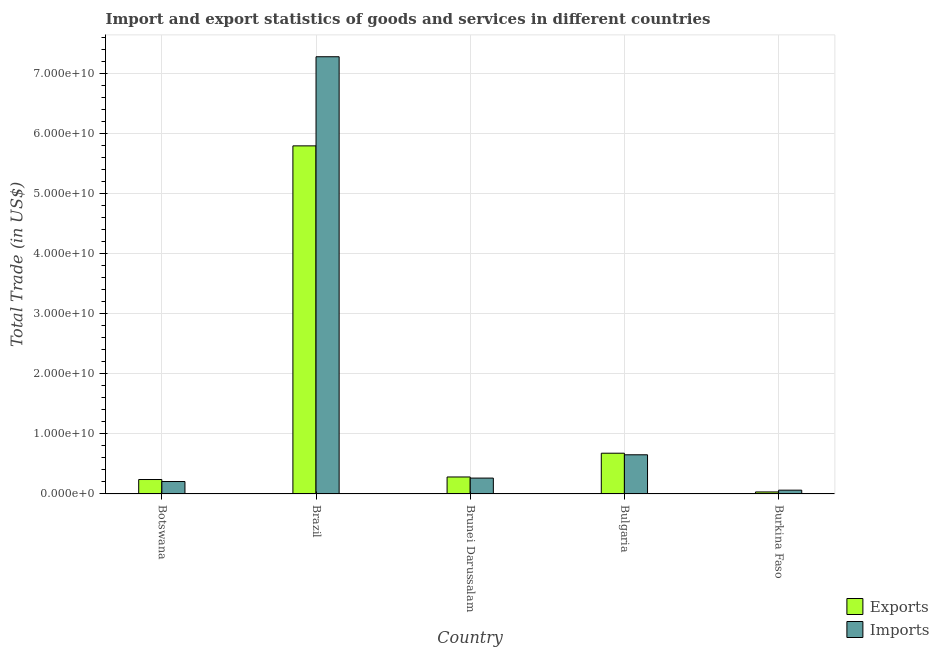How many different coloured bars are there?
Make the answer very short. 2. How many bars are there on the 3rd tick from the left?
Your response must be concise. 2. How many bars are there on the 5th tick from the right?
Provide a short and direct response. 2. What is the label of the 3rd group of bars from the left?
Offer a terse response. Brunei Darussalam. What is the export of goods and services in Brunei Darussalam?
Your response must be concise. 2.83e+09. Across all countries, what is the maximum imports of goods and services?
Offer a terse response. 7.28e+1. Across all countries, what is the minimum export of goods and services?
Provide a short and direct response. 3.36e+08. In which country was the export of goods and services minimum?
Your response must be concise. Burkina Faso. What is the total export of goods and services in the graph?
Your answer should be compact. 7.03e+1. What is the difference between the export of goods and services in Botswana and that in Bulgaria?
Provide a succinct answer. -4.38e+09. What is the difference between the imports of goods and services in Bulgaria and the export of goods and services in Burkina Faso?
Your answer should be compact. 6.18e+09. What is the average export of goods and services per country?
Ensure brevity in your answer.  1.41e+1. What is the difference between the export of goods and services and imports of goods and services in Bulgaria?
Provide a succinct answer. 2.63e+08. In how many countries, is the export of goods and services greater than 40000000000 US$?
Provide a succinct answer. 1. What is the ratio of the export of goods and services in Brunei Darussalam to that in Burkina Faso?
Give a very brief answer. 8.4. Is the export of goods and services in Brazil less than that in Bulgaria?
Give a very brief answer. No. Is the difference between the imports of goods and services in Brunei Darussalam and Bulgaria greater than the difference between the export of goods and services in Brunei Darussalam and Bulgaria?
Your response must be concise. Yes. What is the difference between the highest and the second highest export of goods and services?
Keep it short and to the point. 5.11e+1. What is the difference between the highest and the lowest export of goods and services?
Make the answer very short. 5.76e+1. Is the sum of the export of goods and services in Botswana and Bulgaria greater than the maximum imports of goods and services across all countries?
Provide a succinct answer. No. What does the 1st bar from the left in Burkina Faso represents?
Your answer should be compact. Exports. What does the 2nd bar from the right in Brazil represents?
Give a very brief answer. Exports. How many bars are there?
Offer a very short reply. 10. Are all the bars in the graph horizontal?
Your answer should be very brief. No. What is the difference between two consecutive major ticks on the Y-axis?
Provide a short and direct response. 1.00e+1. Are the values on the major ticks of Y-axis written in scientific E-notation?
Offer a very short reply. Yes. Does the graph contain grids?
Your response must be concise. Yes. How many legend labels are there?
Provide a succinct answer. 2. How are the legend labels stacked?
Keep it short and to the point. Vertical. What is the title of the graph?
Keep it short and to the point. Import and export statistics of goods and services in different countries. Does "Male labor force" appear as one of the legend labels in the graph?
Ensure brevity in your answer.  No. What is the label or title of the X-axis?
Your answer should be compact. Country. What is the label or title of the Y-axis?
Make the answer very short. Total Trade (in US$). What is the Total Trade (in US$) in Exports in Botswana?
Provide a succinct answer. 2.40e+09. What is the Total Trade (in US$) in Imports in Botswana?
Give a very brief answer. 2.07e+09. What is the Total Trade (in US$) of Exports in Brazil?
Give a very brief answer. 5.79e+1. What is the Total Trade (in US$) of Imports in Brazil?
Make the answer very short. 7.28e+1. What is the Total Trade (in US$) in Exports in Brunei Darussalam?
Your answer should be compact. 2.83e+09. What is the Total Trade (in US$) of Imports in Brunei Darussalam?
Provide a short and direct response. 2.64e+09. What is the Total Trade (in US$) of Exports in Bulgaria?
Your response must be concise. 6.78e+09. What is the Total Trade (in US$) in Imports in Bulgaria?
Your response must be concise. 6.52e+09. What is the Total Trade (in US$) of Exports in Burkina Faso?
Your answer should be compact. 3.36e+08. What is the Total Trade (in US$) of Imports in Burkina Faso?
Your response must be concise. 6.33e+08. Across all countries, what is the maximum Total Trade (in US$) in Exports?
Provide a short and direct response. 5.79e+1. Across all countries, what is the maximum Total Trade (in US$) of Imports?
Offer a very short reply. 7.28e+1. Across all countries, what is the minimum Total Trade (in US$) in Exports?
Give a very brief answer. 3.36e+08. Across all countries, what is the minimum Total Trade (in US$) in Imports?
Provide a short and direct response. 6.33e+08. What is the total Total Trade (in US$) of Exports in the graph?
Make the answer very short. 7.03e+1. What is the total Total Trade (in US$) of Imports in the graph?
Your answer should be very brief. 8.46e+1. What is the difference between the Total Trade (in US$) in Exports in Botswana and that in Brazil?
Keep it short and to the point. -5.55e+1. What is the difference between the Total Trade (in US$) of Imports in Botswana and that in Brazil?
Offer a very short reply. -7.07e+1. What is the difference between the Total Trade (in US$) of Exports in Botswana and that in Brunei Darussalam?
Your response must be concise. -4.22e+08. What is the difference between the Total Trade (in US$) in Imports in Botswana and that in Brunei Darussalam?
Give a very brief answer. -5.73e+08. What is the difference between the Total Trade (in US$) of Exports in Botswana and that in Bulgaria?
Your answer should be very brief. -4.38e+09. What is the difference between the Total Trade (in US$) of Imports in Botswana and that in Bulgaria?
Make the answer very short. -4.45e+09. What is the difference between the Total Trade (in US$) of Exports in Botswana and that in Burkina Faso?
Your response must be concise. 2.07e+09. What is the difference between the Total Trade (in US$) of Imports in Botswana and that in Burkina Faso?
Your answer should be compact. 1.44e+09. What is the difference between the Total Trade (in US$) of Exports in Brazil and that in Brunei Darussalam?
Make the answer very short. 5.51e+1. What is the difference between the Total Trade (in US$) of Imports in Brazil and that in Brunei Darussalam?
Make the answer very short. 7.01e+1. What is the difference between the Total Trade (in US$) in Exports in Brazil and that in Bulgaria?
Offer a very short reply. 5.11e+1. What is the difference between the Total Trade (in US$) of Imports in Brazil and that in Bulgaria?
Your answer should be compact. 6.62e+1. What is the difference between the Total Trade (in US$) of Exports in Brazil and that in Burkina Faso?
Provide a succinct answer. 5.76e+1. What is the difference between the Total Trade (in US$) of Imports in Brazil and that in Burkina Faso?
Your answer should be compact. 7.21e+1. What is the difference between the Total Trade (in US$) of Exports in Brunei Darussalam and that in Bulgaria?
Make the answer very short. -3.96e+09. What is the difference between the Total Trade (in US$) in Imports in Brunei Darussalam and that in Bulgaria?
Your answer should be compact. -3.88e+09. What is the difference between the Total Trade (in US$) of Exports in Brunei Darussalam and that in Burkina Faso?
Give a very brief answer. 2.49e+09. What is the difference between the Total Trade (in US$) of Imports in Brunei Darussalam and that in Burkina Faso?
Your answer should be very brief. 2.01e+09. What is the difference between the Total Trade (in US$) of Exports in Bulgaria and that in Burkina Faso?
Ensure brevity in your answer.  6.45e+09. What is the difference between the Total Trade (in US$) in Imports in Bulgaria and that in Burkina Faso?
Your answer should be very brief. 5.89e+09. What is the difference between the Total Trade (in US$) in Exports in Botswana and the Total Trade (in US$) in Imports in Brazil?
Give a very brief answer. -7.03e+1. What is the difference between the Total Trade (in US$) in Exports in Botswana and the Total Trade (in US$) in Imports in Brunei Darussalam?
Provide a succinct answer. -2.38e+08. What is the difference between the Total Trade (in US$) of Exports in Botswana and the Total Trade (in US$) of Imports in Bulgaria?
Offer a terse response. -4.11e+09. What is the difference between the Total Trade (in US$) of Exports in Botswana and the Total Trade (in US$) of Imports in Burkina Faso?
Provide a succinct answer. 1.77e+09. What is the difference between the Total Trade (in US$) in Exports in Brazil and the Total Trade (in US$) in Imports in Brunei Darussalam?
Keep it short and to the point. 5.53e+1. What is the difference between the Total Trade (in US$) in Exports in Brazil and the Total Trade (in US$) in Imports in Bulgaria?
Provide a succinct answer. 5.14e+1. What is the difference between the Total Trade (in US$) of Exports in Brazil and the Total Trade (in US$) of Imports in Burkina Faso?
Give a very brief answer. 5.73e+1. What is the difference between the Total Trade (in US$) in Exports in Brunei Darussalam and the Total Trade (in US$) in Imports in Bulgaria?
Keep it short and to the point. -3.69e+09. What is the difference between the Total Trade (in US$) of Exports in Brunei Darussalam and the Total Trade (in US$) of Imports in Burkina Faso?
Provide a short and direct response. 2.19e+09. What is the difference between the Total Trade (in US$) of Exports in Bulgaria and the Total Trade (in US$) of Imports in Burkina Faso?
Keep it short and to the point. 6.15e+09. What is the average Total Trade (in US$) of Exports per country?
Provide a succinct answer. 1.41e+1. What is the average Total Trade (in US$) of Imports per country?
Offer a terse response. 1.69e+1. What is the difference between the Total Trade (in US$) of Exports and Total Trade (in US$) of Imports in Botswana?
Offer a very short reply. 3.35e+08. What is the difference between the Total Trade (in US$) of Exports and Total Trade (in US$) of Imports in Brazil?
Provide a succinct answer. -1.48e+1. What is the difference between the Total Trade (in US$) of Exports and Total Trade (in US$) of Imports in Brunei Darussalam?
Ensure brevity in your answer.  1.84e+08. What is the difference between the Total Trade (in US$) in Exports and Total Trade (in US$) in Imports in Bulgaria?
Your response must be concise. 2.63e+08. What is the difference between the Total Trade (in US$) of Exports and Total Trade (in US$) of Imports in Burkina Faso?
Give a very brief answer. -2.97e+08. What is the ratio of the Total Trade (in US$) of Exports in Botswana to that in Brazil?
Keep it short and to the point. 0.04. What is the ratio of the Total Trade (in US$) of Imports in Botswana to that in Brazil?
Keep it short and to the point. 0.03. What is the ratio of the Total Trade (in US$) in Exports in Botswana to that in Brunei Darussalam?
Your response must be concise. 0.85. What is the ratio of the Total Trade (in US$) of Imports in Botswana to that in Brunei Darussalam?
Provide a succinct answer. 0.78. What is the ratio of the Total Trade (in US$) in Exports in Botswana to that in Bulgaria?
Offer a very short reply. 0.35. What is the ratio of the Total Trade (in US$) in Imports in Botswana to that in Bulgaria?
Offer a terse response. 0.32. What is the ratio of the Total Trade (in US$) in Exports in Botswana to that in Burkina Faso?
Ensure brevity in your answer.  7.15. What is the ratio of the Total Trade (in US$) in Imports in Botswana to that in Burkina Faso?
Keep it short and to the point. 3.27. What is the ratio of the Total Trade (in US$) in Exports in Brazil to that in Brunei Darussalam?
Offer a terse response. 20.49. What is the ratio of the Total Trade (in US$) of Imports in Brazil to that in Brunei Darussalam?
Your answer should be very brief. 27.53. What is the ratio of the Total Trade (in US$) of Exports in Brazil to that in Bulgaria?
Offer a very short reply. 8.54. What is the ratio of the Total Trade (in US$) in Imports in Brazil to that in Bulgaria?
Keep it short and to the point. 11.16. What is the ratio of the Total Trade (in US$) in Exports in Brazil to that in Burkina Faso?
Keep it short and to the point. 172.14. What is the ratio of the Total Trade (in US$) in Imports in Brazil to that in Burkina Faso?
Provide a short and direct response. 114.91. What is the ratio of the Total Trade (in US$) of Exports in Brunei Darussalam to that in Bulgaria?
Offer a very short reply. 0.42. What is the ratio of the Total Trade (in US$) in Imports in Brunei Darussalam to that in Bulgaria?
Provide a succinct answer. 0.41. What is the ratio of the Total Trade (in US$) of Exports in Brunei Darussalam to that in Burkina Faso?
Your answer should be very brief. 8.4. What is the ratio of the Total Trade (in US$) of Imports in Brunei Darussalam to that in Burkina Faso?
Your response must be concise. 4.17. What is the ratio of the Total Trade (in US$) of Exports in Bulgaria to that in Burkina Faso?
Offer a terse response. 20.16. What is the ratio of the Total Trade (in US$) in Imports in Bulgaria to that in Burkina Faso?
Your answer should be compact. 10.3. What is the difference between the highest and the second highest Total Trade (in US$) of Exports?
Offer a very short reply. 5.11e+1. What is the difference between the highest and the second highest Total Trade (in US$) in Imports?
Offer a very short reply. 6.62e+1. What is the difference between the highest and the lowest Total Trade (in US$) of Exports?
Your answer should be compact. 5.76e+1. What is the difference between the highest and the lowest Total Trade (in US$) in Imports?
Offer a terse response. 7.21e+1. 